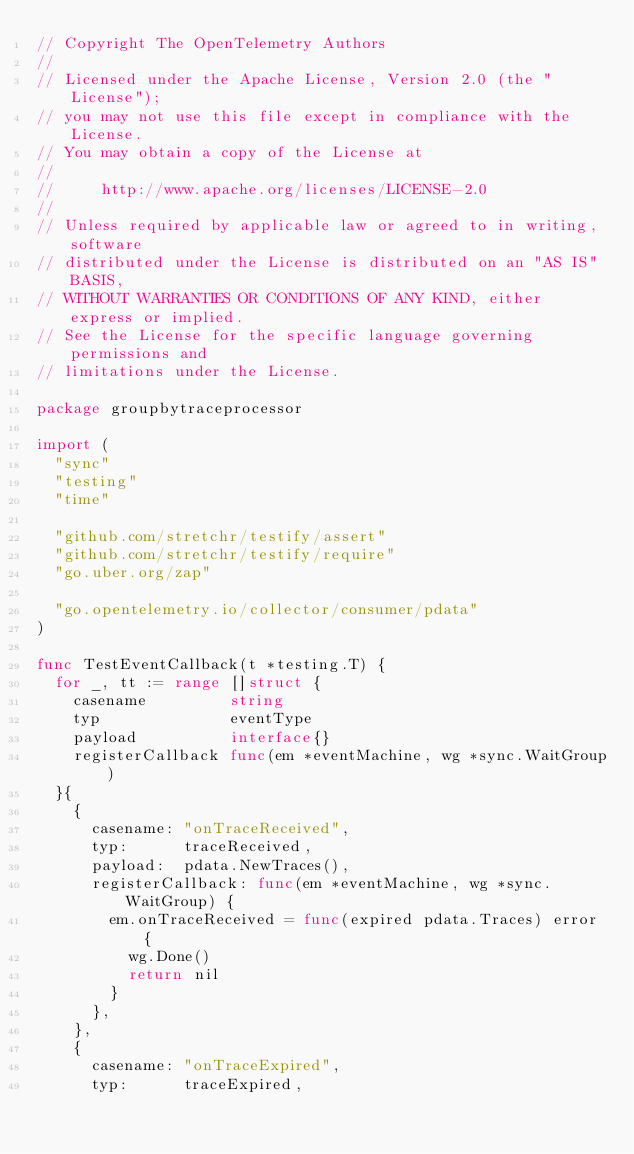<code> <loc_0><loc_0><loc_500><loc_500><_Go_>// Copyright The OpenTelemetry Authors
//
// Licensed under the Apache License, Version 2.0 (the "License");
// you may not use this file except in compliance with the License.
// You may obtain a copy of the License at
//
//     http://www.apache.org/licenses/LICENSE-2.0
//
// Unless required by applicable law or agreed to in writing, software
// distributed under the License is distributed on an "AS IS" BASIS,
// WITHOUT WARRANTIES OR CONDITIONS OF ANY KIND, either express or implied.
// See the License for the specific language governing permissions and
// limitations under the License.

package groupbytraceprocessor

import (
	"sync"
	"testing"
	"time"

	"github.com/stretchr/testify/assert"
	"github.com/stretchr/testify/require"
	"go.uber.org/zap"

	"go.opentelemetry.io/collector/consumer/pdata"
)

func TestEventCallback(t *testing.T) {
	for _, tt := range []struct {
		casename         string
		typ              eventType
		payload          interface{}
		registerCallback func(em *eventMachine, wg *sync.WaitGroup)
	}{
		{
			casename: "onTraceReceived",
			typ:      traceReceived,
			payload:  pdata.NewTraces(),
			registerCallback: func(em *eventMachine, wg *sync.WaitGroup) {
				em.onTraceReceived = func(expired pdata.Traces) error {
					wg.Done()
					return nil
				}
			},
		},
		{
			casename: "onTraceExpired",
			typ:      traceExpired,</code> 